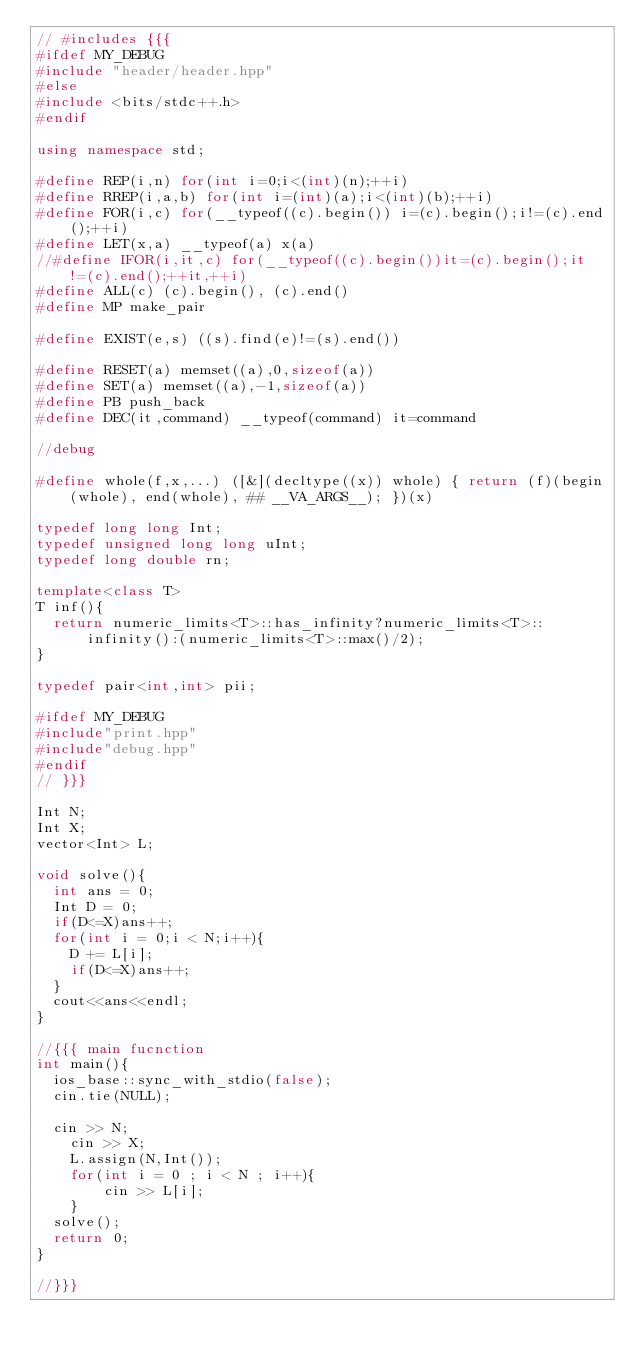Convert code to text. <code><loc_0><loc_0><loc_500><loc_500><_C++_>// #includes {{{
#ifdef MY_DEBUG
#include "header/header.hpp"
#else
#include <bits/stdc++.h>
#endif

using namespace std;

#define REP(i,n) for(int i=0;i<(int)(n);++i)
#define RREP(i,a,b) for(int i=(int)(a);i<(int)(b);++i)
#define FOR(i,c) for(__typeof((c).begin()) i=(c).begin();i!=(c).end();++i)
#define LET(x,a) __typeof(a) x(a)
//#define IFOR(i,it,c) for(__typeof((c).begin())it=(c).begin();it!=(c).end();++it,++i)
#define ALL(c) (c).begin(), (c).end()
#define MP make_pair

#define EXIST(e,s) ((s).find(e)!=(s).end())

#define RESET(a) memset((a),0,sizeof(a))
#define SET(a) memset((a),-1,sizeof(a))
#define PB push_back
#define DEC(it,command) __typeof(command) it=command

//debug

#define whole(f,x,...) ([&](decltype((x)) whole) { return (f)(begin(whole), end(whole), ## __VA_ARGS__); })(x)

typedef long long Int;
typedef unsigned long long uInt;
typedef long double rn;

template<class T>
T inf(){
	return numeric_limits<T>::has_infinity?numeric_limits<T>::infinity():(numeric_limits<T>::max()/2);
}

typedef pair<int,int> pii;

#ifdef MY_DEBUG
#include"print.hpp"
#include"debug.hpp"
#endif
// }}}

Int N;
Int X;
vector<Int> L;

void solve(){
	int ans = 0;
	Int D = 0;
	if(D<=X)ans++;
	for(int i = 0;i < N;i++){
		D += L[i];
		if(D<=X)ans++;
	}
	cout<<ans<<endl;
}

//{{{ main fucnction
int main(){
	ios_base::sync_with_stdio(false);
	cin.tie(NULL);

	cin >> N;
    cin >> X;
    L.assign(N,Int());
    for(int i = 0 ; i < N ; i++){
        cin >> L[i];
    }
	solve();
	return 0;
}

//}}}

</code> 